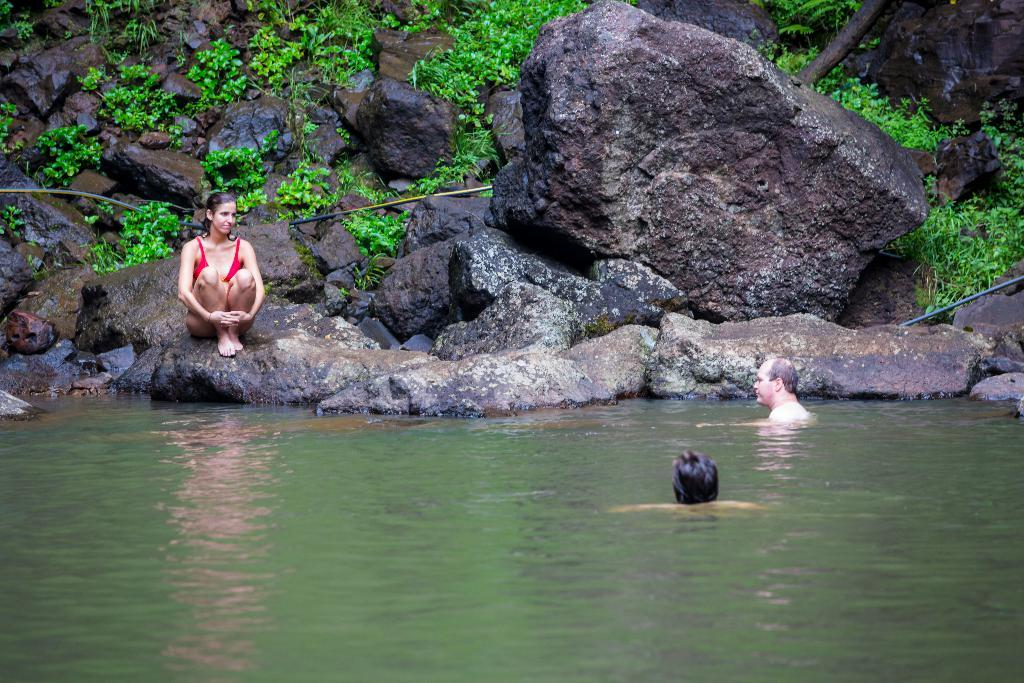What are the two people in the image doing? The two people in the image are swimming in the water. Can you describe the woman's location in the image? The woman is on a rock in the image. What can be found on the rock with the woman? Plants are present on the rock. What type of flock can be seen flying over the water in the image? There is no flock visible in the image; it only shows two people swimming and a woman on a rock. How many fish are visible in the water in the image? There are no fish visible in the water in the image; it only shows two people swimming. 